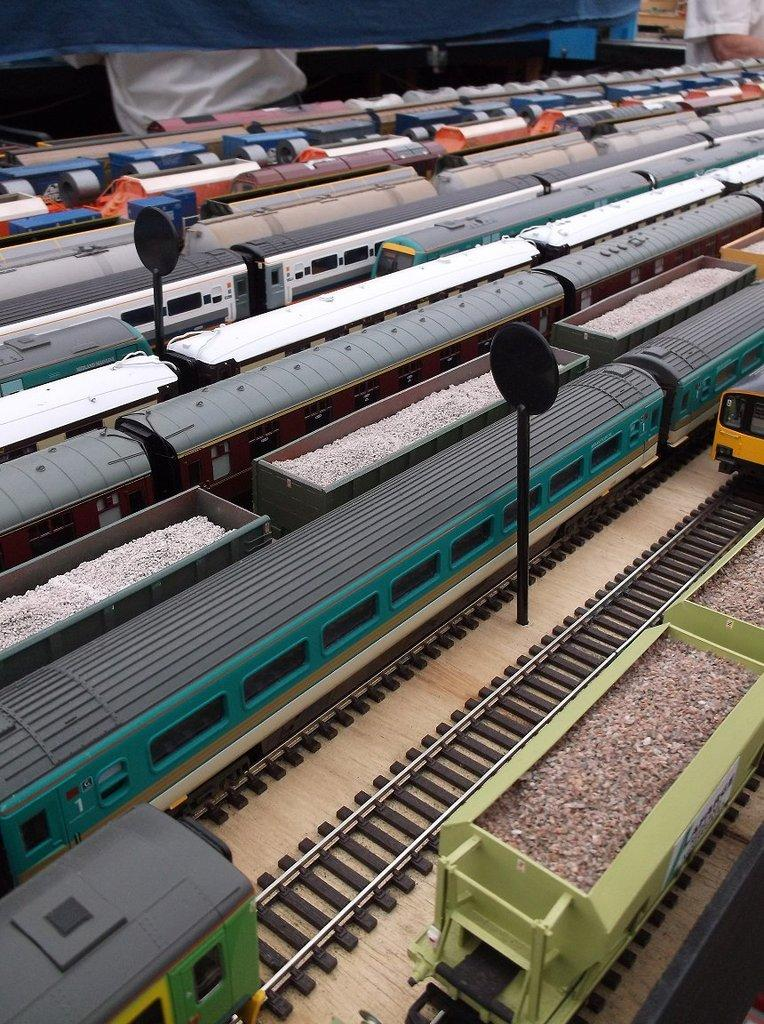What type of image is being depicted? The image is a miniature. What can be seen moving on the tracks in the image? There are trains in the image. What are the tracks used for in the image? The tracks are used by the trains in the image. What type of acoustics can be heard from the trains in the image? There is no sound present in the image, so it is not possible to determine the acoustics of the trains. 